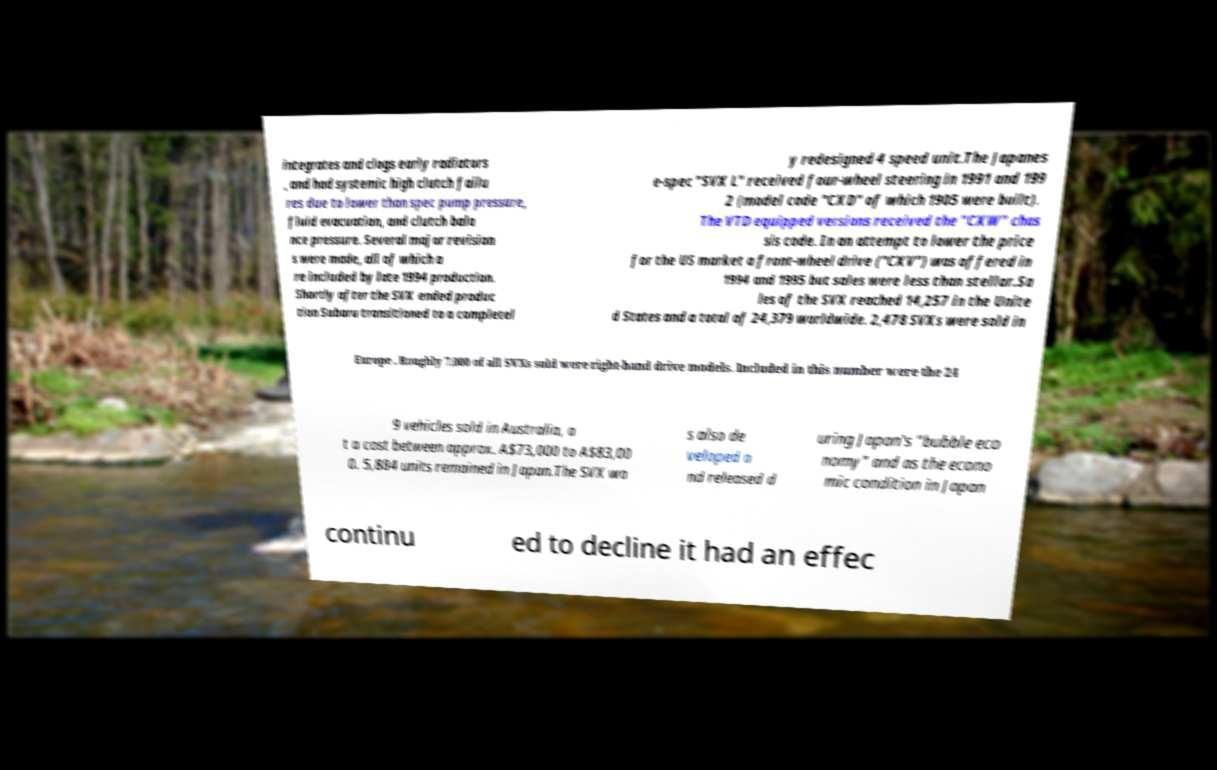Please identify and transcribe the text found in this image. integrates and clogs early radiators , and had systemic high clutch failu res due to lower than spec pump pressure, fluid evacuation, and clutch bala nce pressure. Several major revision s were made, all of which a re included by late 1994 production. Shortly after the SVX ended produc tion Subaru transitioned to a completel y redesigned 4 speed unit.The Japanes e-spec "SVX L" received four-wheel steering in 1991 and 199 2 (model code "CXD" of which 1905 were built). The VTD equipped versions received the "CXW" chas sis code. In an attempt to lower the price for the US market a front-wheel drive ("CXV") was offered in 1994 and 1995 but sales were less than stellar.Sa les of the SVX reached 14,257 in the Unite d States and a total of 24,379 worldwide. 2,478 SVXs were sold in Europe . Roughly 7,000 of all SVXs sold were right-hand drive models. Included in this number were the 24 9 vehicles sold in Australia, a t a cost between approx. A$73,000 to A$83,00 0. 5,884 units remained in Japan.The SVX wa s also de veloped a nd released d uring Japan's "bubble eco nomy" and as the econo mic condition in Japan continu ed to decline it had an effec 